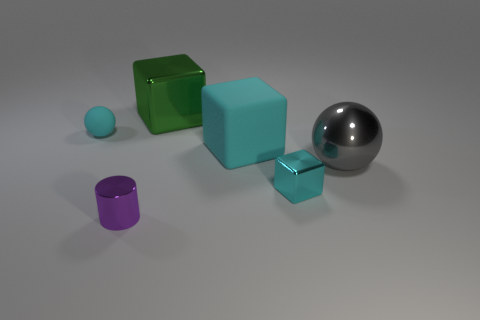Subtract all green cubes. Subtract all cyan balls. How many cubes are left? 2 Add 4 tiny yellow matte balls. How many objects exist? 10 Subtract all balls. How many objects are left? 4 Subtract all green metallic cylinders. Subtract all small shiny blocks. How many objects are left? 5 Add 3 large gray things. How many large gray things are left? 4 Add 4 big gray blocks. How many big gray blocks exist? 4 Subtract 0 gray blocks. How many objects are left? 6 